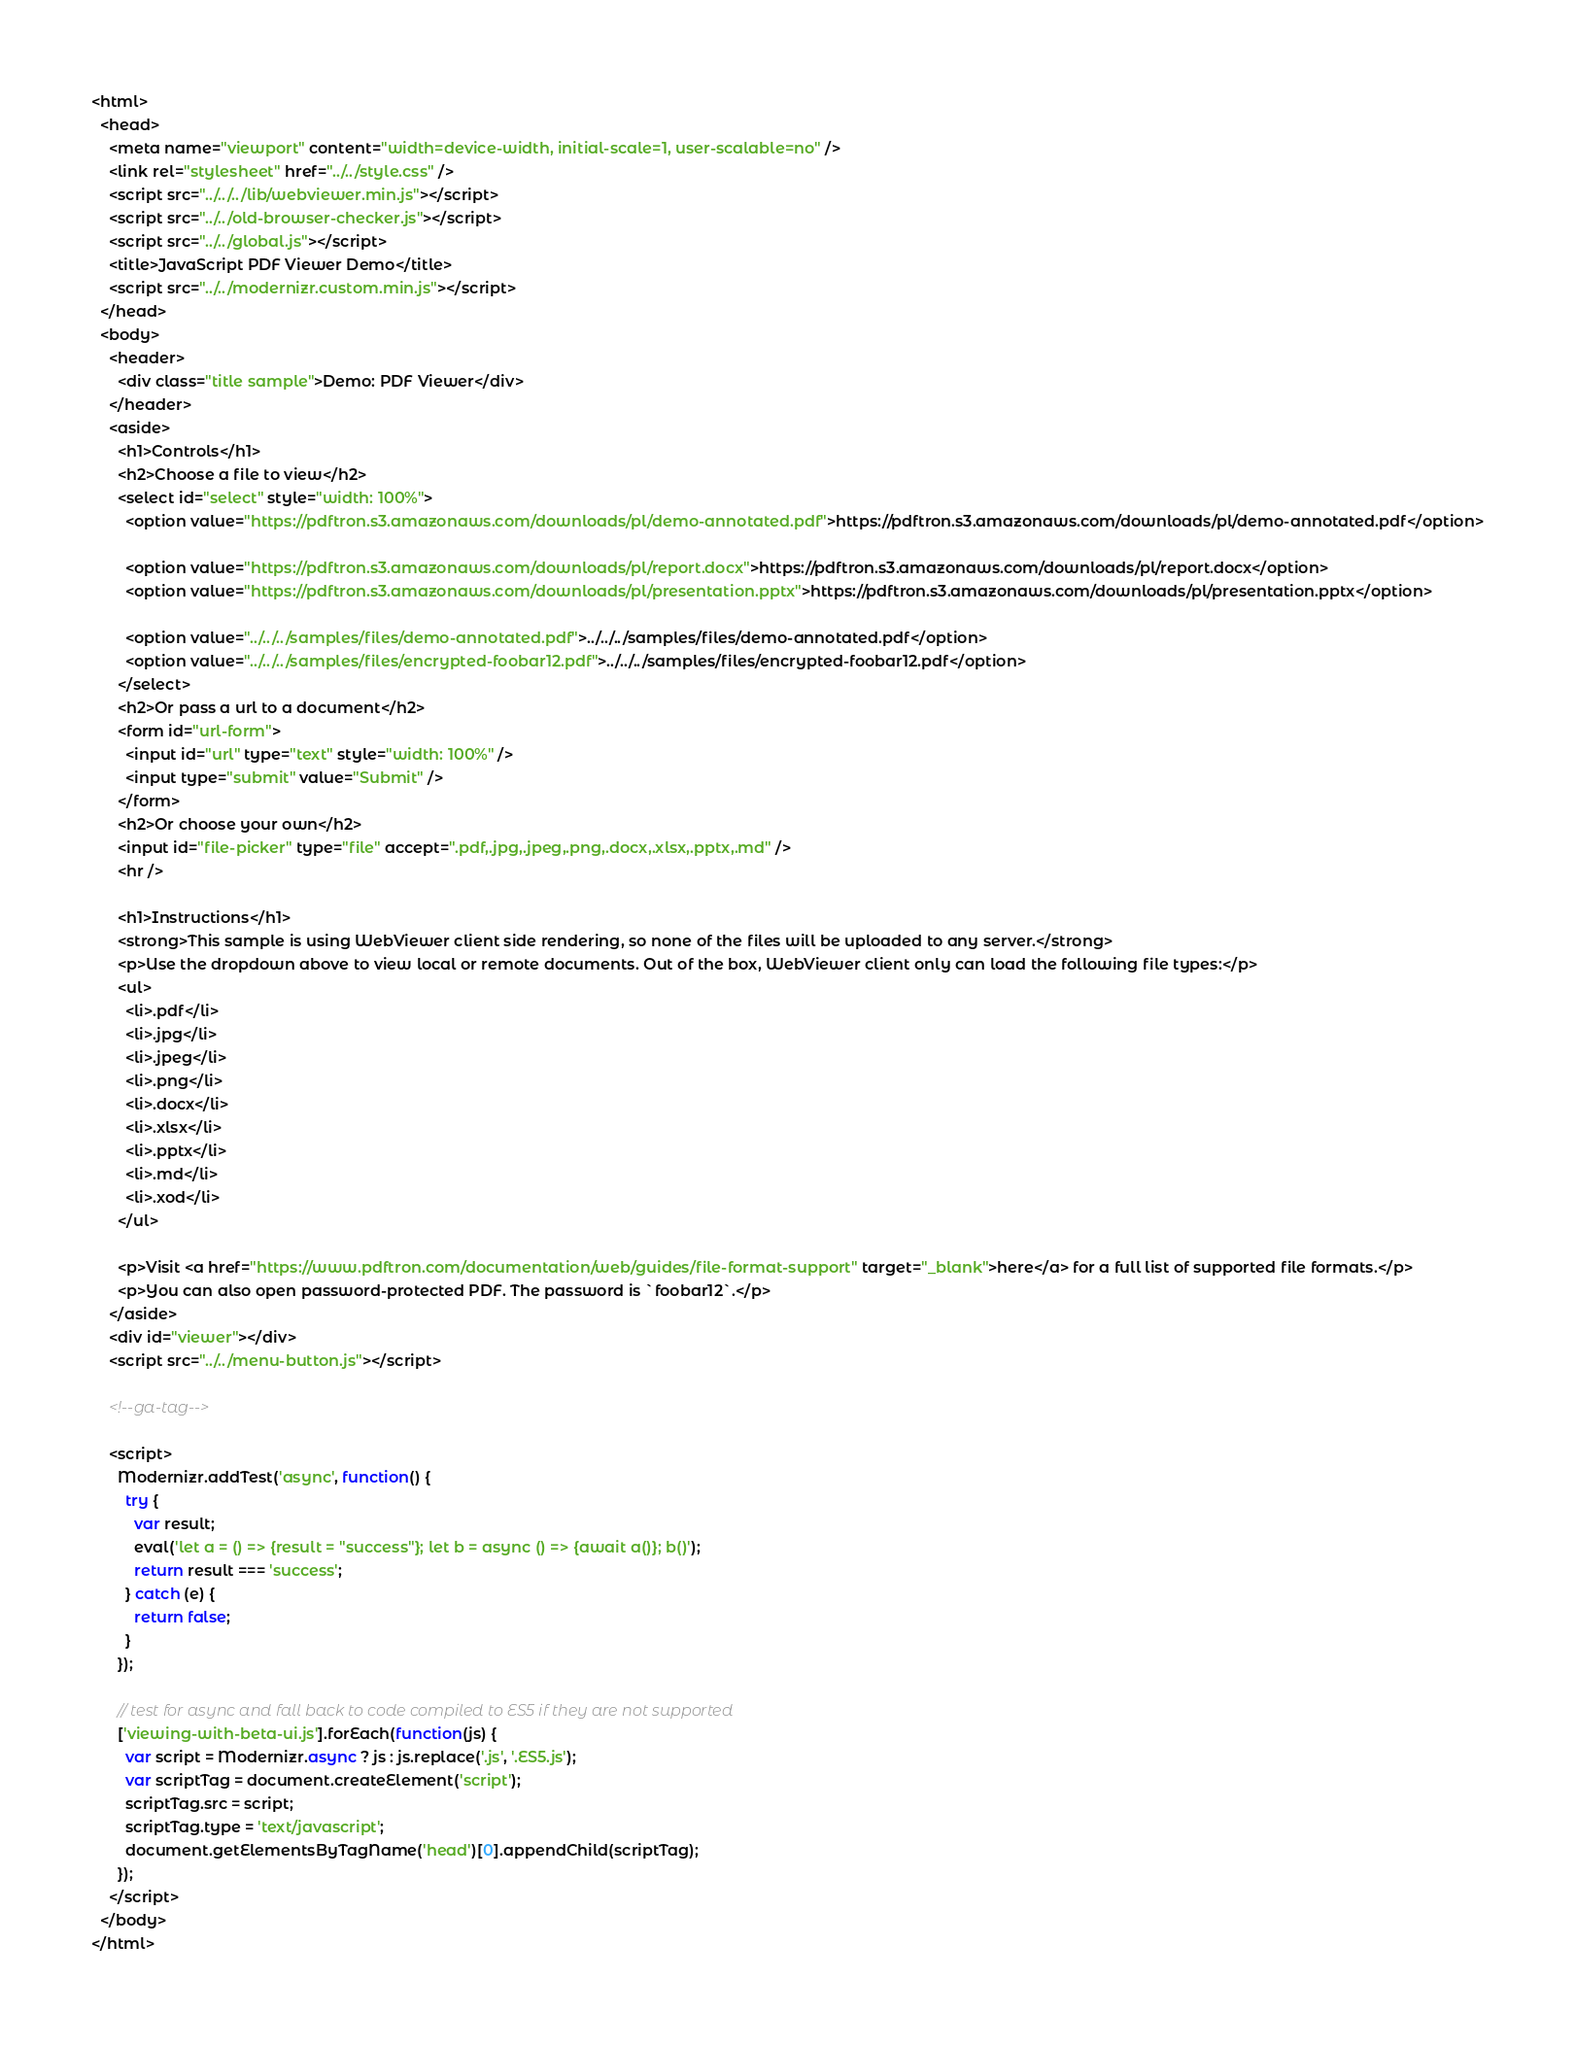<code> <loc_0><loc_0><loc_500><loc_500><_HTML_><html>
  <head>
    <meta name="viewport" content="width=device-width, initial-scale=1, user-scalable=no" />
    <link rel="stylesheet" href="../../style.css" />
    <script src="../../../lib/webviewer.min.js"></script>
    <script src="../../old-browser-checker.js"></script>
    <script src="../../global.js"></script>
    <title>JavaScript PDF Viewer Demo</title>
    <script src="../../modernizr.custom.min.js"></script>
  </head>
  <body>
    <header>
      <div class="title sample">Demo: PDF Viewer</div>
    </header>
    <aside>
      <h1>Controls</h1>
      <h2>Choose a file to view</h2>
      <select id="select" style="width: 100%">
        <option value="https://pdftron.s3.amazonaws.com/downloads/pl/demo-annotated.pdf">https://pdftron.s3.amazonaws.com/downloads/pl/demo-annotated.pdf</option>

        <option value="https://pdftron.s3.amazonaws.com/downloads/pl/report.docx">https://pdftron.s3.amazonaws.com/downloads/pl/report.docx</option>
        <option value="https://pdftron.s3.amazonaws.com/downloads/pl/presentation.pptx">https://pdftron.s3.amazonaws.com/downloads/pl/presentation.pptx</option>

        <option value="../../../samples/files/demo-annotated.pdf">../../../samples/files/demo-annotated.pdf</option>
        <option value="../../../samples/files/encrypted-foobar12.pdf">../../../samples/files/encrypted-foobar12.pdf</option>
      </select>
      <h2>Or pass a url to a document</h2>
      <form id="url-form">
        <input id="url" type="text" style="width: 100%" />
        <input type="submit" value="Submit" />
      </form>
      <h2>Or choose your own</h2>
      <input id="file-picker" type="file" accept=".pdf,.jpg,.jpeg,.png,.docx,.xlsx,.pptx,.md" />
      <hr />

      <h1>Instructions</h1>
      <strong>This sample is using WebViewer client side rendering, so none of the files will be uploaded to any server.</strong>
      <p>Use the dropdown above to view local or remote documents. Out of the box, WebViewer client only can load the following file types:</p>
      <ul>
        <li>.pdf</li>
        <li>.jpg</li>
        <li>.jpeg</li>
        <li>.png</li>
        <li>.docx</li>
        <li>.xlsx</li>
        <li>.pptx</li>
        <li>.md</li>
        <li>.xod</li>
      </ul>

      <p>Visit <a href="https://www.pdftron.com/documentation/web/guides/file-format-support" target="_blank">here</a> for a full list of supported file formats.</p>
      <p>You can also open password-protected PDF. The password is `foobar12`.</p>
    </aside>
    <div id="viewer"></div>
    <script src="../../menu-button.js"></script>

    <!--ga-tag-->

    <script>
      Modernizr.addTest('async', function() {
        try {
          var result;
          eval('let a = () => {result = "success"}; let b = async () => {await a()}; b()');
          return result === 'success';
        } catch (e) {
          return false;
        }
      });

      // test for async and fall back to code compiled to ES5 if they are not supported
      ['viewing-with-beta-ui.js'].forEach(function(js) {
        var script = Modernizr.async ? js : js.replace('.js', '.ES5.js');
        var scriptTag = document.createElement('script');
        scriptTag.src = script;
        scriptTag.type = 'text/javascript';
        document.getElementsByTagName('head')[0].appendChild(scriptTag);
      });
    </script>
  </body>
</html>
</code> 